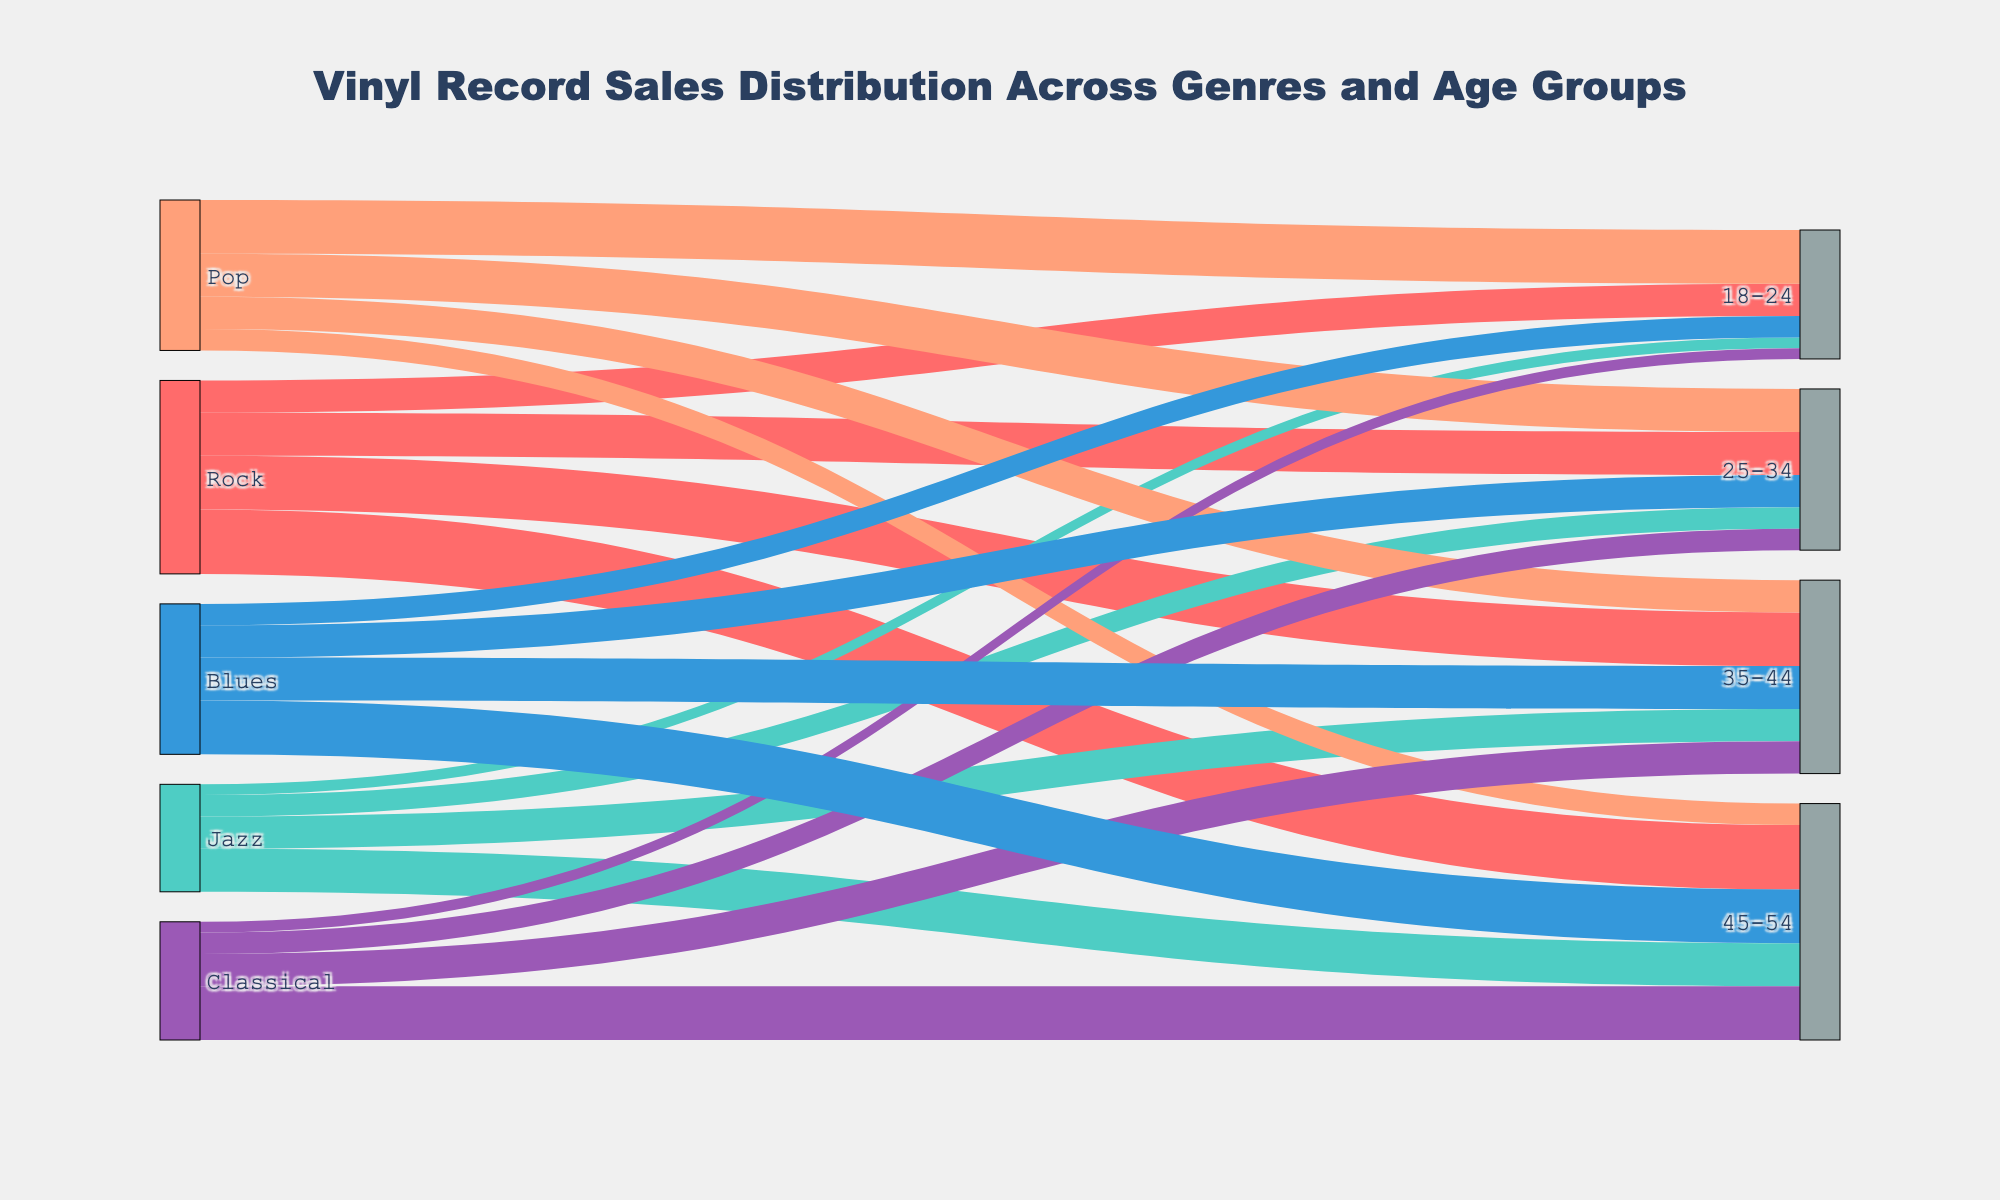Which genre has the highest vinyl sales in the 45-54 age group? From the Sankey diagram, look for the genre with the thickest link leading to the 45-54 age group. The thickest link indicates the highest sales.
Answer: Rock What is the total vinyl sales for the 25-34 age group across all genres? Sum the values for all genres linking to the 25-34 age group: Rock (20) + Jazz (10) + Pop (20) + Classical (10) + Blues (15). The total sales are calculated as 20 + 10 + 20 + 10 + 15 = 75.
Answer: 75 Which age group has the lowest vinyl sales for Pop? By inspecting the links connected to Pop, identify the smallest value. The value for 45-54 age group is 10, which is the lowest among all age groups for Pop.
Answer: 45-54 How do the vinyl sales for Rock compare to those for Jazz in the 35-44 age group? Check the values for Rock and Jazz in the 35-44 age group. Rock has 25 sales, while Jazz has 15 sales. Hence, Rock sales (25) are greater than Jazz sales (15) in this age group.
Answer: Rock sales are greater What percentage of total vinyl sales does the 18-24 age group represent for Classical? First, sum the values for all age groups in Classical: 5 (18-24) + 10 (25-34) + 15 (35-44) + 25 (45-54) = 55. The percentage for the 18-24 age group is (5/55) * 100 = 9.09%.
Answer: 9.09% If you combine the vinyl sales for the 35-44 age group across Pop and Blues, how many more sales does this combined value have over Jazz in the same age group? Sum the values for Pop (15) and Blues (20) in the 35-44 age group: 15 + 20 = 35. Then subtract Jazz's sales (15). 35 - 15 = 20.
Answer: 20 more sales Which age group has the most balanced distribution of vinyl sales across all genres? Inspect all the age groups and compare the distribution of sales. The 25-34 age group has a relatively balanced distribution: Rock (20), Jazz (10), Pop (20), Classical (10), Blues (15).
Answer: 25-34 What's the average vinyl sales for Blues across all age groups? Sum the vinyl sales for Blues in all age groups: 10 (18-24) + 15 (25-34) + 20 (35-44) + 25 (45-54) = 70. Divide by 4 (the number of age groups): 70 / 4 = 17.5.
Answer: 17.5 